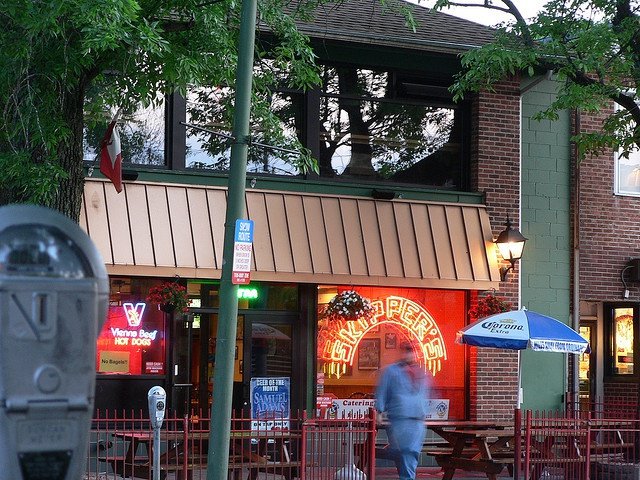Describe the objects in this image and their specific colors. I can see parking meter in darkgreen, gray, blue, and black tones, bench in darkgreen, black, maroon, gray, and purple tones, people in darkgreen, gray, blue, and navy tones, umbrella in darkgreen, lightblue, blue, white, and navy tones, and dining table in darkgreen, black, maroon, gray, and brown tones in this image. 